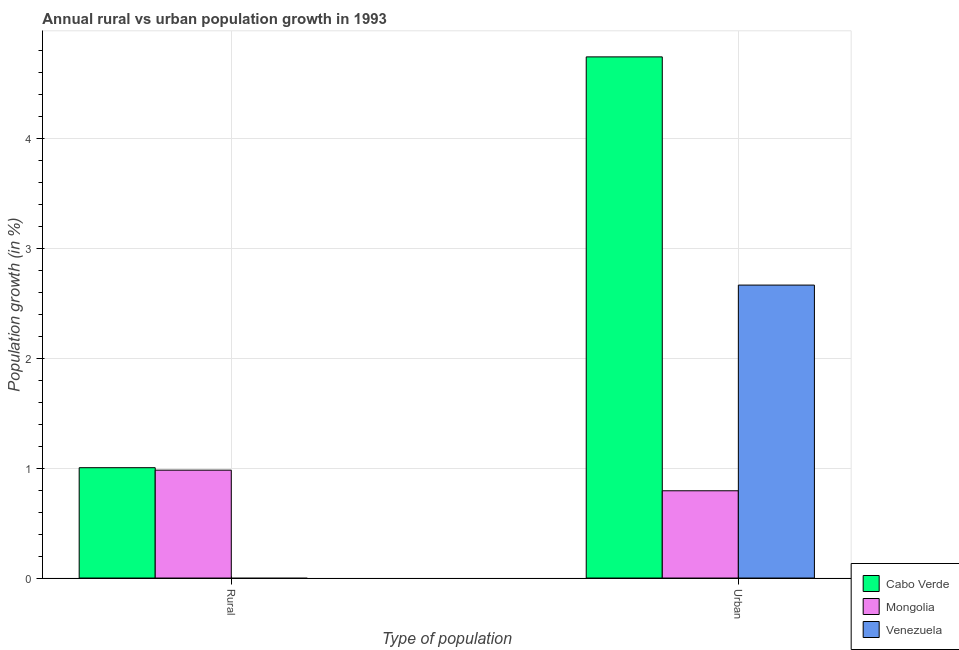How many different coloured bars are there?
Ensure brevity in your answer.  3. How many groups of bars are there?
Provide a succinct answer. 2. Are the number of bars on each tick of the X-axis equal?
Your answer should be compact. No. What is the label of the 1st group of bars from the left?
Provide a succinct answer. Rural. What is the urban population growth in Cabo Verde?
Offer a terse response. 4.74. Across all countries, what is the maximum rural population growth?
Your answer should be compact. 1. Across all countries, what is the minimum urban population growth?
Your answer should be compact. 0.79. In which country was the rural population growth maximum?
Provide a succinct answer. Cabo Verde. What is the total rural population growth in the graph?
Your answer should be very brief. 1.98. What is the difference between the urban population growth in Cabo Verde and that in Venezuela?
Keep it short and to the point. 2.07. What is the difference between the urban population growth in Venezuela and the rural population growth in Cabo Verde?
Your response must be concise. 1.66. What is the average rural population growth per country?
Provide a succinct answer. 0.66. What is the difference between the rural population growth and urban population growth in Mongolia?
Your response must be concise. 0.19. What is the ratio of the rural population growth in Mongolia to that in Cabo Verde?
Give a very brief answer. 0.98. Are all the bars in the graph horizontal?
Ensure brevity in your answer.  No. How many countries are there in the graph?
Provide a short and direct response. 3. Does the graph contain any zero values?
Offer a terse response. Yes. Does the graph contain grids?
Provide a short and direct response. Yes. What is the title of the graph?
Your response must be concise. Annual rural vs urban population growth in 1993. Does "Comoros" appear as one of the legend labels in the graph?
Provide a short and direct response. No. What is the label or title of the X-axis?
Your answer should be very brief. Type of population. What is the label or title of the Y-axis?
Offer a terse response. Population growth (in %). What is the Population growth (in %) in Cabo Verde in Rural?
Your answer should be very brief. 1. What is the Population growth (in %) in Mongolia in Rural?
Give a very brief answer. 0.98. What is the Population growth (in %) in Cabo Verde in Urban ?
Give a very brief answer. 4.74. What is the Population growth (in %) in Mongolia in Urban ?
Your answer should be very brief. 0.79. What is the Population growth (in %) in Venezuela in Urban ?
Ensure brevity in your answer.  2.66. Across all Type of population, what is the maximum Population growth (in %) of Cabo Verde?
Provide a succinct answer. 4.74. Across all Type of population, what is the maximum Population growth (in %) in Mongolia?
Make the answer very short. 0.98. Across all Type of population, what is the maximum Population growth (in %) of Venezuela?
Your response must be concise. 2.66. Across all Type of population, what is the minimum Population growth (in %) in Cabo Verde?
Your answer should be very brief. 1. Across all Type of population, what is the minimum Population growth (in %) in Mongolia?
Offer a very short reply. 0.79. Across all Type of population, what is the minimum Population growth (in %) of Venezuela?
Offer a very short reply. 0. What is the total Population growth (in %) in Cabo Verde in the graph?
Ensure brevity in your answer.  5.74. What is the total Population growth (in %) in Mongolia in the graph?
Provide a short and direct response. 1.77. What is the total Population growth (in %) of Venezuela in the graph?
Offer a terse response. 2.66. What is the difference between the Population growth (in %) in Cabo Verde in Rural and that in Urban ?
Your answer should be compact. -3.74. What is the difference between the Population growth (in %) in Mongolia in Rural and that in Urban ?
Ensure brevity in your answer.  0.19. What is the difference between the Population growth (in %) of Cabo Verde in Rural and the Population growth (in %) of Mongolia in Urban?
Provide a short and direct response. 0.21. What is the difference between the Population growth (in %) of Cabo Verde in Rural and the Population growth (in %) of Venezuela in Urban?
Your answer should be compact. -1.66. What is the difference between the Population growth (in %) of Mongolia in Rural and the Population growth (in %) of Venezuela in Urban?
Provide a succinct answer. -1.68. What is the average Population growth (in %) in Cabo Verde per Type of population?
Offer a terse response. 2.87. What is the average Population growth (in %) in Mongolia per Type of population?
Give a very brief answer. 0.89. What is the average Population growth (in %) of Venezuela per Type of population?
Make the answer very short. 1.33. What is the difference between the Population growth (in %) in Cabo Verde and Population growth (in %) in Mongolia in Rural?
Give a very brief answer. 0.02. What is the difference between the Population growth (in %) in Cabo Verde and Population growth (in %) in Mongolia in Urban ?
Your answer should be very brief. 3.95. What is the difference between the Population growth (in %) of Cabo Verde and Population growth (in %) of Venezuela in Urban ?
Ensure brevity in your answer.  2.07. What is the difference between the Population growth (in %) of Mongolia and Population growth (in %) of Venezuela in Urban ?
Your answer should be very brief. -1.87. What is the ratio of the Population growth (in %) of Cabo Verde in Rural to that in Urban ?
Make the answer very short. 0.21. What is the ratio of the Population growth (in %) of Mongolia in Rural to that in Urban ?
Keep it short and to the point. 1.24. What is the difference between the highest and the second highest Population growth (in %) of Cabo Verde?
Your answer should be very brief. 3.74. What is the difference between the highest and the second highest Population growth (in %) of Mongolia?
Your response must be concise. 0.19. What is the difference between the highest and the lowest Population growth (in %) in Cabo Verde?
Provide a short and direct response. 3.74. What is the difference between the highest and the lowest Population growth (in %) in Mongolia?
Provide a succinct answer. 0.19. What is the difference between the highest and the lowest Population growth (in %) in Venezuela?
Offer a very short reply. 2.66. 